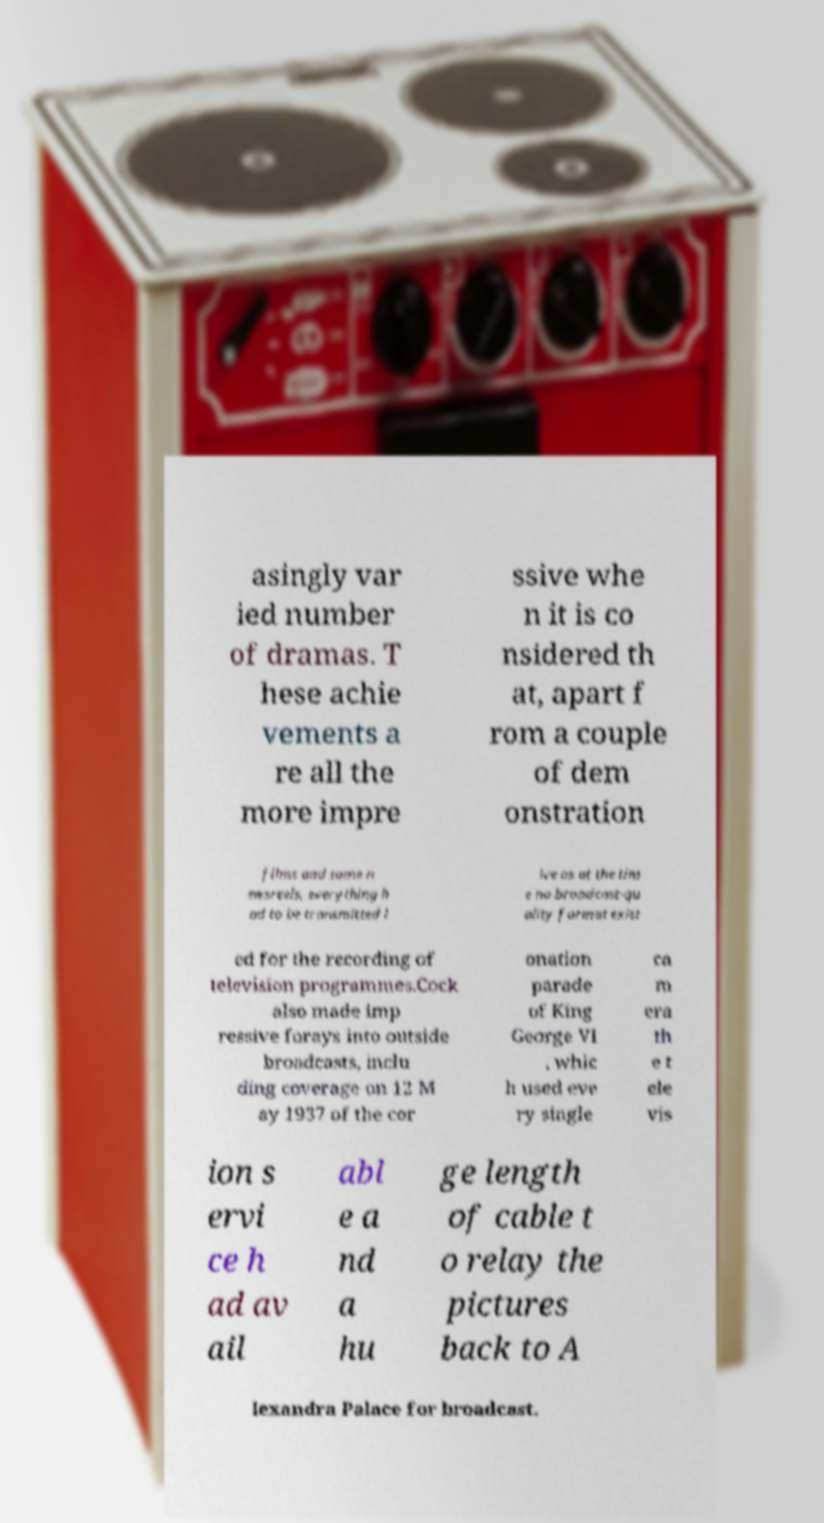Could you assist in decoding the text presented in this image and type it out clearly? asingly var ied number of dramas. T hese achie vements a re all the more impre ssive whe n it is co nsidered th at, apart f rom a couple of dem onstration films and some n ewsreels, everything h ad to be transmitted l ive as at the tim e no broadcast-qu ality format exist ed for the recording of television programmes.Cock also made imp ressive forays into outside broadcasts, inclu ding coverage on 12 M ay 1937 of the cor onation parade of King George VI , whic h used eve ry single ca m era th e t ele vis ion s ervi ce h ad av ail abl e a nd a hu ge length of cable t o relay the pictures back to A lexandra Palace for broadcast. 